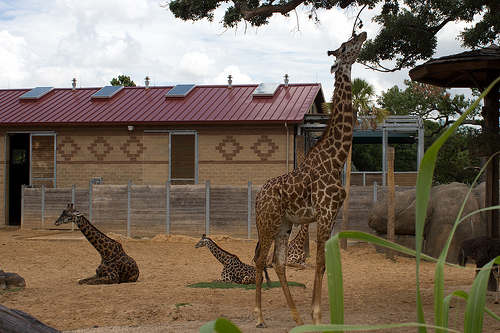If these giraffes could talk, what do you think they would be discussing? Imagine the giraffes having a conversation—perhaps they are discussing their day. The standing giraffe might be recounting the moments it spent observing visitors and enjoying the foliage, while the ones lying down could share amusing anecdotes of their interactions or speculate about the food they will receive. They might also express their concerns about the weather changes, wondering if it will rain or remain sunny. This imagined dialogue adds a layer of personality and camaraderie to the scene, making it more engaging and whimsical. 